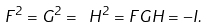Convert formula to latex. <formula><loc_0><loc_0><loc_500><loc_500>F ^ { 2 } = G ^ { 2 } = \text { } H ^ { 2 } = F G H = - I .</formula> 